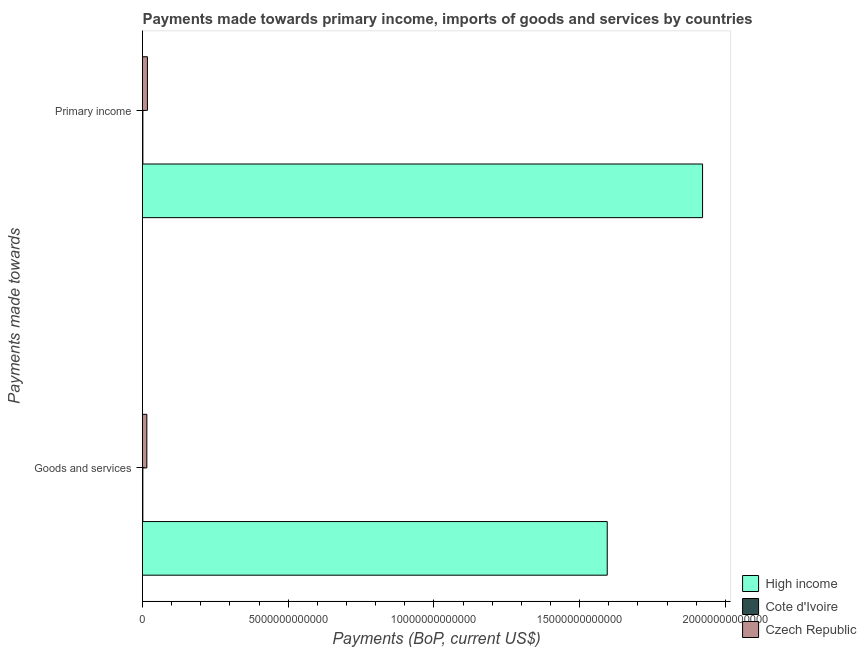How many groups of bars are there?
Keep it short and to the point. 2. How many bars are there on the 1st tick from the top?
Make the answer very short. 3. How many bars are there on the 1st tick from the bottom?
Give a very brief answer. 3. What is the label of the 2nd group of bars from the top?
Keep it short and to the point. Goods and services. What is the payments made towards primary income in High income?
Your answer should be very brief. 1.92e+13. Across all countries, what is the maximum payments made towards goods and services?
Your response must be concise. 1.59e+13. Across all countries, what is the minimum payments made towards primary income?
Provide a short and direct response. 1.32e+1. In which country was the payments made towards primary income maximum?
Offer a terse response. High income. In which country was the payments made towards goods and services minimum?
Give a very brief answer. Cote d'Ivoire. What is the total payments made towards goods and services in the graph?
Offer a terse response. 1.61e+13. What is the difference between the payments made towards goods and services in High income and that in Czech Republic?
Ensure brevity in your answer.  1.58e+13. What is the difference between the payments made towards goods and services in High income and the payments made towards primary income in Czech Republic?
Keep it short and to the point. 1.58e+13. What is the average payments made towards primary income per country?
Make the answer very short. 6.47e+12. What is the difference between the payments made towards goods and services and payments made towards primary income in Cote d'Ivoire?
Ensure brevity in your answer.  -1.11e+09. In how many countries, is the payments made towards goods and services greater than 17000000000000 US$?
Your response must be concise. 0. What is the ratio of the payments made towards goods and services in Czech Republic to that in Cote d'Ivoire?
Keep it short and to the point. 12.34. Is the payments made towards primary income in Cote d'Ivoire less than that in Czech Republic?
Your answer should be very brief. Yes. In how many countries, is the payments made towards primary income greater than the average payments made towards primary income taken over all countries?
Ensure brevity in your answer.  1. What does the 3rd bar from the top in Goods and services represents?
Provide a short and direct response. High income. How many bars are there?
Give a very brief answer. 6. Are all the bars in the graph horizontal?
Your response must be concise. Yes. How many countries are there in the graph?
Give a very brief answer. 3. What is the difference between two consecutive major ticks on the X-axis?
Your answer should be very brief. 5.00e+12. Where does the legend appear in the graph?
Make the answer very short. Bottom right. How many legend labels are there?
Your answer should be very brief. 3. What is the title of the graph?
Offer a terse response. Payments made towards primary income, imports of goods and services by countries. Does "Italy" appear as one of the legend labels in the graph?
Your answer should be very brief. No. What is the label or title of the X-axis?
Ensure brevity in your answer.  Payments (BoP, current US$). What is the label or title of the Y-axis?
Ensure brevity in your answer.  Payments made towards. What is the Payments (BoP, current US$) of High income in Goods and services?
Your answer should be very brief. 1.59e+13. What is the Payments (BoP, current US$) of Cote d'Ivoire in Goods and services?
Your answer should be very brief. 1.21e+1. What is the Payments (BoP, current US$) in Czech Republic in Goods and services?
Your response must be concise. 1.49e+11. What is the Payments (BoP, current US$) of High income in Primary income?
Keep it short and to the point. 1.92e+13. What is the Payments (BoP, current US$) of Cote d'Ivoire in Primary income?
Ensure brevity in your answer.  1.32e+1. What is the Payments (BoP, current US$) in Czech Republic in Primary income?
Keep it short and to the point. 1.68e+11. Across all Payments made towards, what is the maximum Payments (BoP, current US$) of High income?
Your answer should be very brief. 1.92e+13. Across all Payments made towards, what is the maximum Payments (BoP, current US$) of Cote d'Ivoire?
Make the answer very short. 1.32e+1. Across all Payments made towards, what is the maximum Payments (BoP, current US$) in Czech Republic?
Provide a succinct answer. 1.68e+11. Across all Payments made towards, what is the minimum Payments (BoP, current US$) in High income?
Provide a short and direct response. 1.59e+13. Across all Payments made towards, what is the minimum Payments (BoP, current US$) of Cote d'Ivoire?
Your response must be concise. 1.21e+1. Across all Payments made towards, what is the minimum Payments (BoP, current US$) of Czech Republic?
Provide a succinct answer. 1.49e+11. What is the total Payments (BoP, current US$) in High income in the graph?
Offer a terse response. 3.52e+13. What is the total Payments (BoP, current US$) of Cote d'Ivoire in the graph?
Provide a short and direct response. 2.52e+1. What is the total Payments (BoP, current US$) in Czech Republic in the graph?
Ensure brevity in your answer.  3.17e+11. What is the difference between the Payments (BoP, current US$) of High income in Goods and services and that in Primary income?
Offer a terse response. -3.27e+12. What is the difference between the Payments (BoP, current US$) of Cote d'Ivoire in Goods and services and that in Primary income?
Keep it short and to the point. -1.11e+09. What is the difference between the Payments (BoP, current US$) in Czech Republic in Goods and services and that in Primary income?
Provide a succinct answer. -1.96e+1. What is the difference between the Payments (BoP, current US$) of High income in Goods and services and the Payments (BoP, current US$) of Cote d'Ivoire in Primary income?
Provide a short and direct response. 1.59e+13. What is the difference between the Payments (BoP, current US$) of High income in Goods and services and the Payments (BoP, current US$) of Czech Republic in Primary income?
Ensure brevity in your answer.  1.58e+13. What is the difference between the Payments (BoP, current US$) in Cote d'Ivoire in Goods and services and the Payments (BoP, current US$) in Czech Republic in Primary income?
Give a very brief answer. -1.56e+11. What is the average Payments (BoP, current US$) in High income per Payments made towards?
Offer a terse response. 1.76e+13. What is the average Payments (BoP, current US$) in Cote d'Ivoire per Payments made towards?
Provide a short and direct response. 1.26e+1. What is the average Payments (BoP, current US$) of Czech Republic per Payments made towards?
Keep it short and to the point. 1.59e+11. What is the difference between the Payments (BoP, current US$) in High income and Payments (BoP, current US$) in Cote d'Ivoire in Goods and services?
Provide a short and direct response. 1.59e+13. What is the difference between the Payments (BoP, current US$) of High income and Payments (BoP, current US$) of Czech Republic in Goods and services?
Give a very brief answer. 1.58e+13. What is the difference between the Payments (BoP, current US$) of Cote d'Ivoire and Payments (BoP, current US$) of Czech Republic in Goods and services?
Provide a short and direct response. -1.37e+11. What is the difference between the Payments (BoP, current US$) in High income and Payments (BoP, current US$) in Cote d'Ivoire in Primary income?
Provide a succinct answer. 1.92e+13. What is the difference between the Payments (BoP, current US$) in High income and Payments (BoP, current US$) in Czech Republic in Primary income?
Ensure brevity in your answer.  1.90e+13. What is the difference between the Payments (BoP, current US$) in Cote d'Ivoire and Payments (BoP, current US$) in Czech Republic in Primary income?
Your response must be concise. -1.55e+11. What is the ratio of the Payments (BoP, current US$) of High income in Goods and services to that in Primary income?
Keep it short and to the point. 0.83. What is the ratio of the Payments (BoP, current US$) in Cote d'Ivoire in Goods and services to that in Primary income?
Offer a very short reply. 0.92. What is the ratio of the Payments (BoP, current US$) of Czech Republic in Goods and services to that in Primary income?
Your answer should be very brief. 0.88. What is the difference between the highest and the second highest Payments (BoP, current US$) in High income?
Keep it short and to the point. 3.27e+12. What is the difference between the highest and the second highest Payments (BoP, current US$) in Cote d'Ivoire?
Your answer should be very brief. 1.11e+09. What is the difference between the highest and the second highest Payments (BoP, current US$) in Czech Republic?
Ensure brevity in your answer.  1.96e+1. What is the difference between the highest and the lowest Payments (BoP, current US$) of High income?
Make the answer very short. 3.27e+12. What is the difference between the highest and the lowest Payments (BoP, current US$) in Cote d'Ivoire?
Offer a very short reply. 1.11e+09. What is the difference between the highest and the lowest Payments (BoP, current US$) of Czech Republic?
Keep it short and to the point. 1.96e+1. 